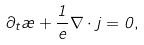Convert formula to latex. <formula><loc_0><loc_0><loc_500><loc_500>\partial _ { t } \rho + \frac { 1 } { e } \nabla \cdot { j } = 0 ,</formula> 